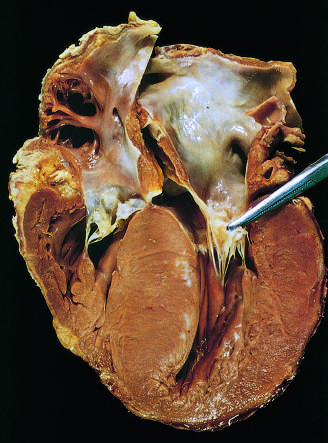what has been moved away from the septum to reveal a fibrous endocardial plaque?
Answer the question using a single word or phrase. The anterior mitral leaflet 